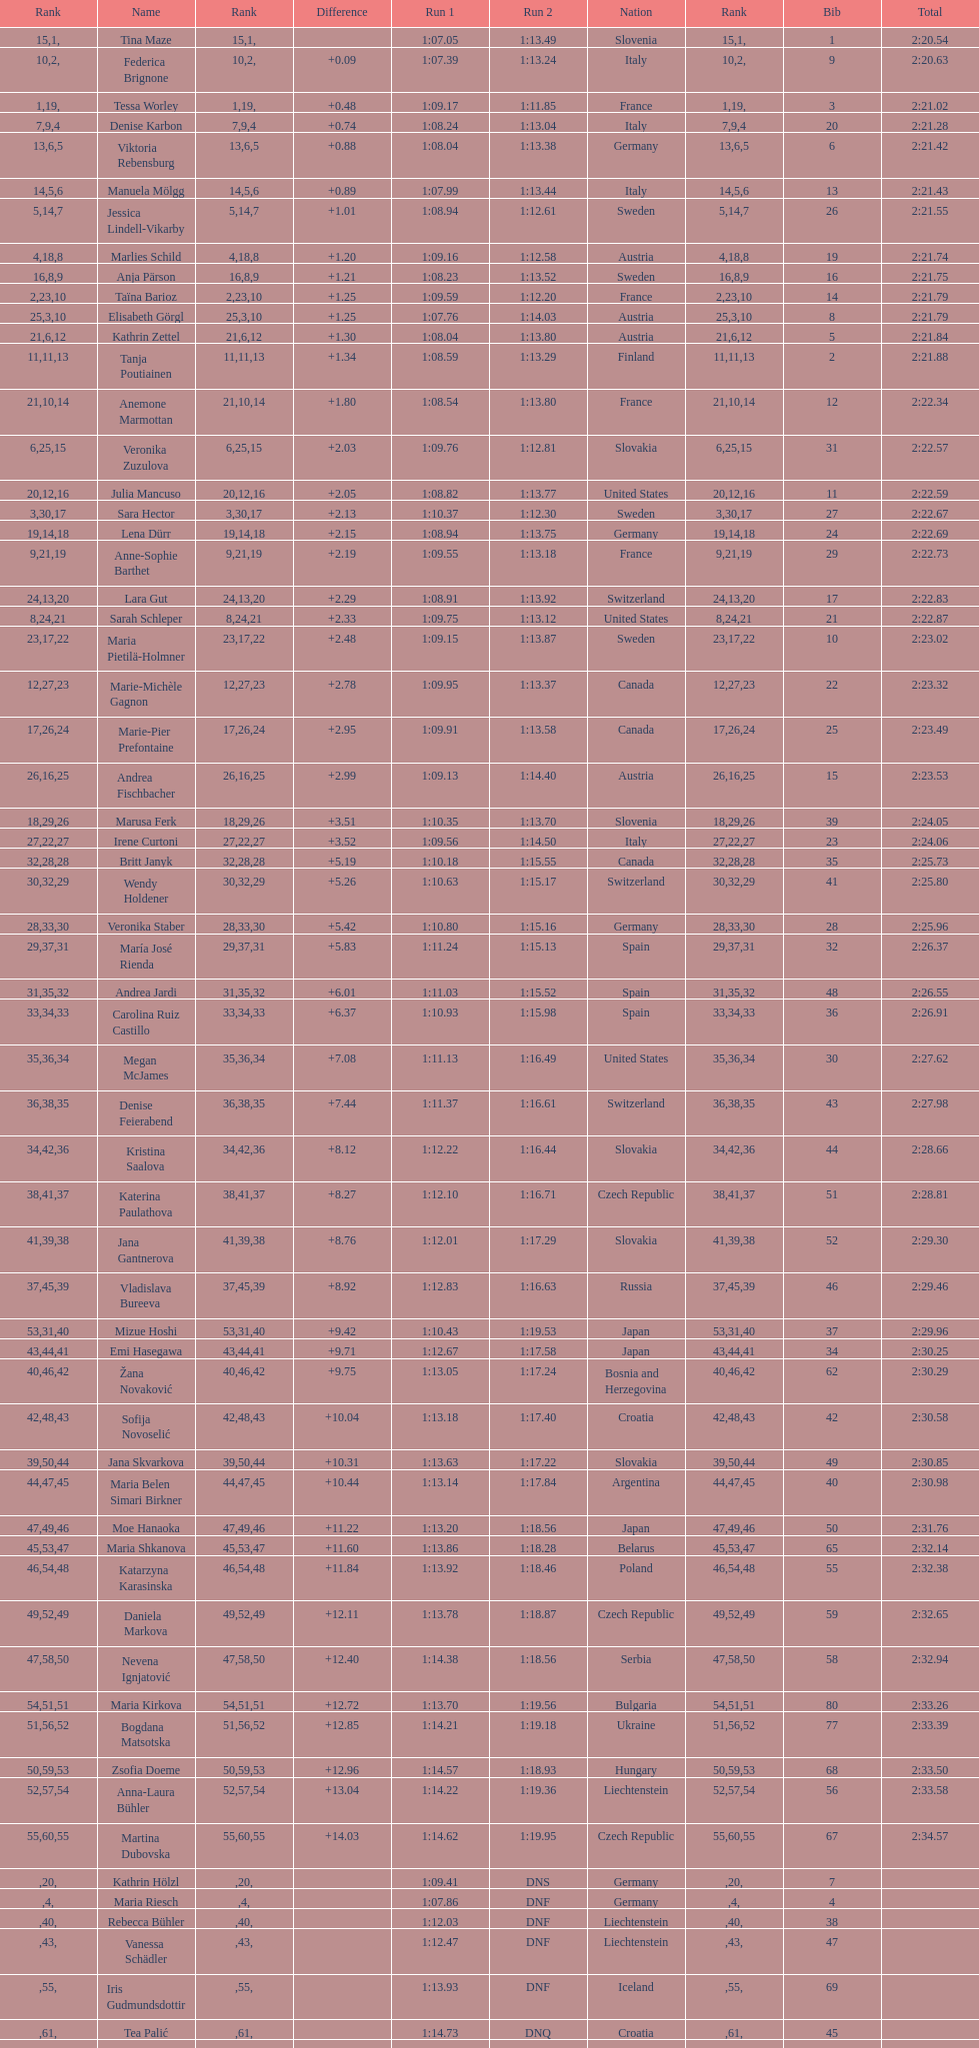What is the name before anja parson? Marlies Schild. 